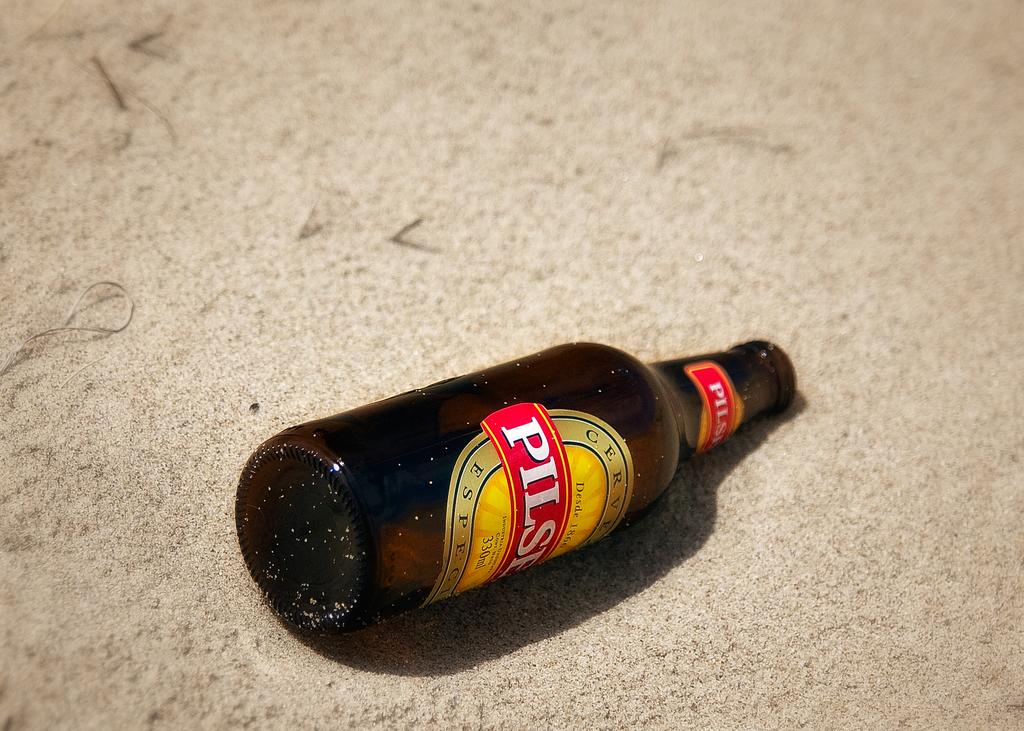How many milliliters is this bottle?
Provide a succinct answer. 330. What letter does the bottle's name start with?
Keep it short and to the point. P. 